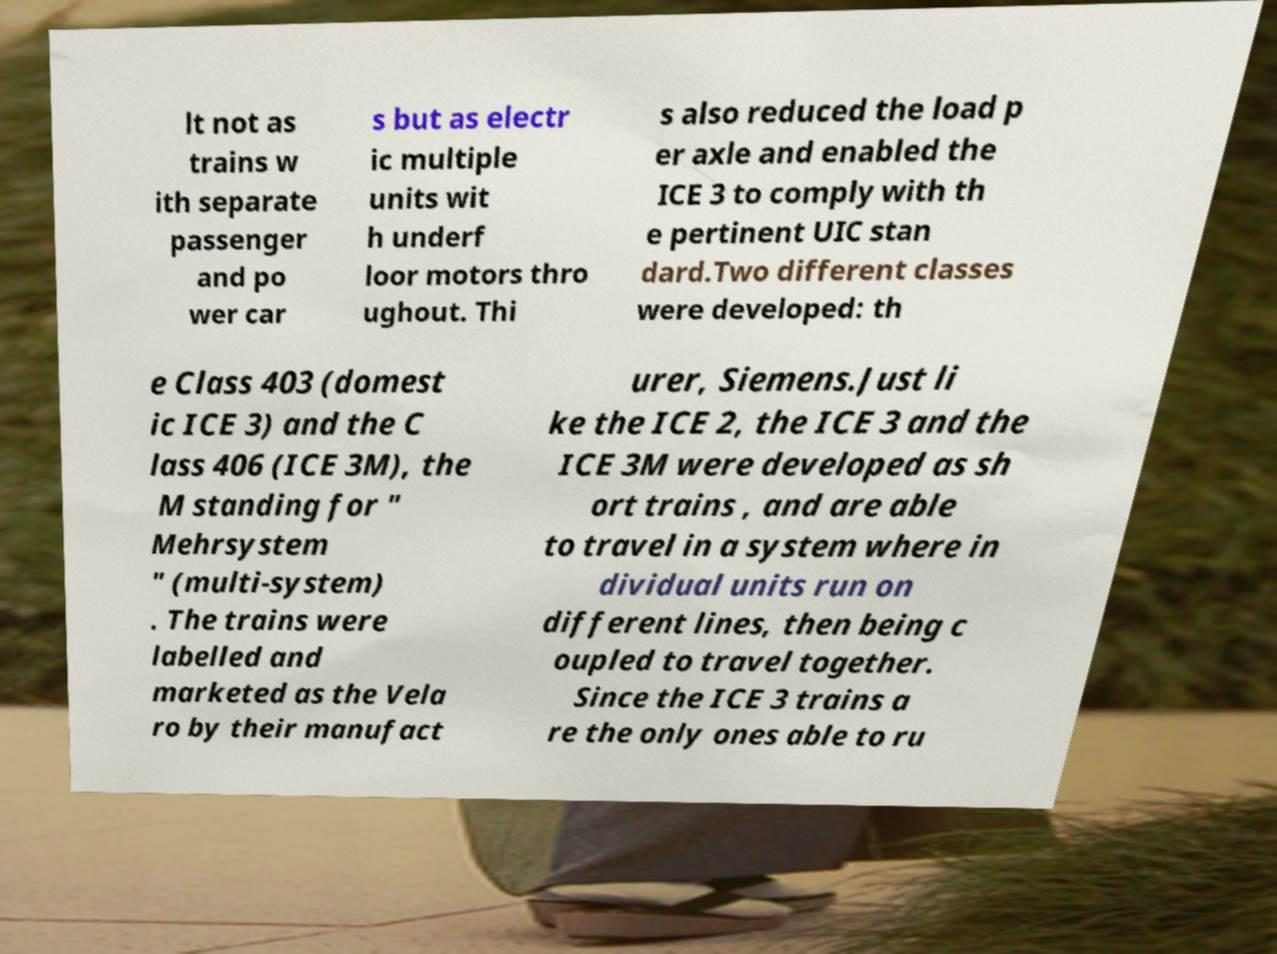For documentation purposes, I need the text within this image transcribed. Could you provide that? lt not as trains w ith separate passenger and po wer car s but as electr ic multiple units wit h underf loor motors thro ughout. Thi s also reduced the load p er axle and enabled the ICE 3 to comply with th e pertinent UIC stan dard.Two different classes were developed: th e Class 403 (domest ic ICE 3) and the C lass 406 (ICE 3M), the M standing for " Mehrsystem " (multi-system) . The trains were labelled and marketed as the Vela ro by their manufact urer, Siemens.Just li ke the ICE 2, the ICE 3 and the ICE 3M were developed as sh ort trains , and are able to travel in a system where in dividual units run on different lines, then being c oupled to travel together. Since the ICE 3 trains a re the only ones able to ru 